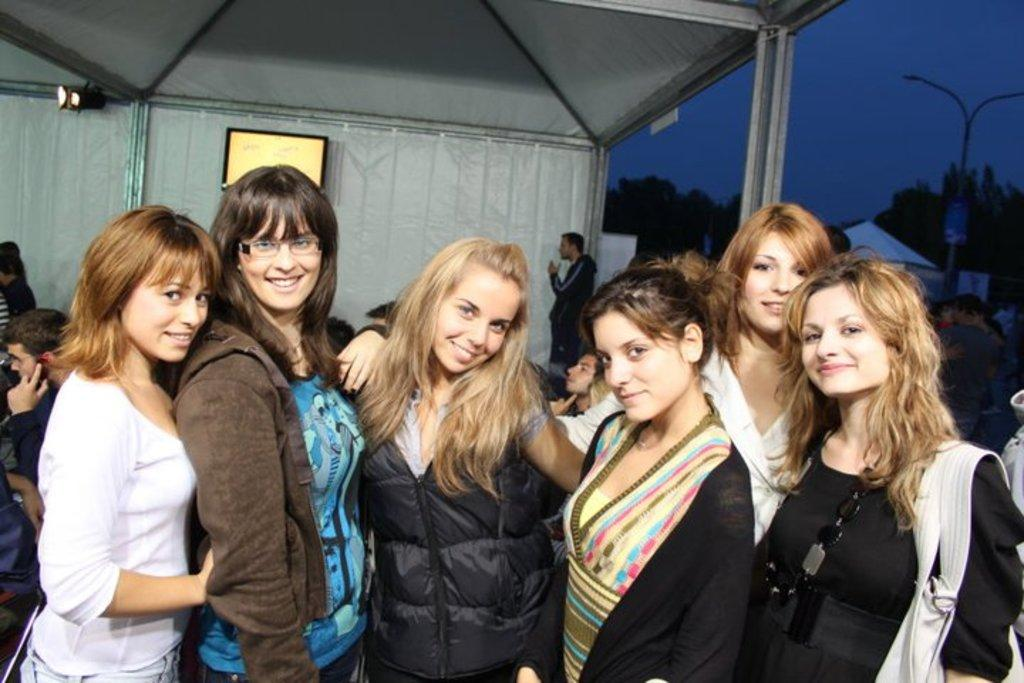What are the people in the image doing? The people in the image are standing under a tent. What can be seen in the background of the image? There are trees and a light pole in the background of the image. What is visible in the sky in the image? The sky is visible in the background of the image. Where is the mailbox located in the image? There is no mailbox present in the image. What type of bottle can be seen on the table in the image? There is no table or bottle present in the image. 